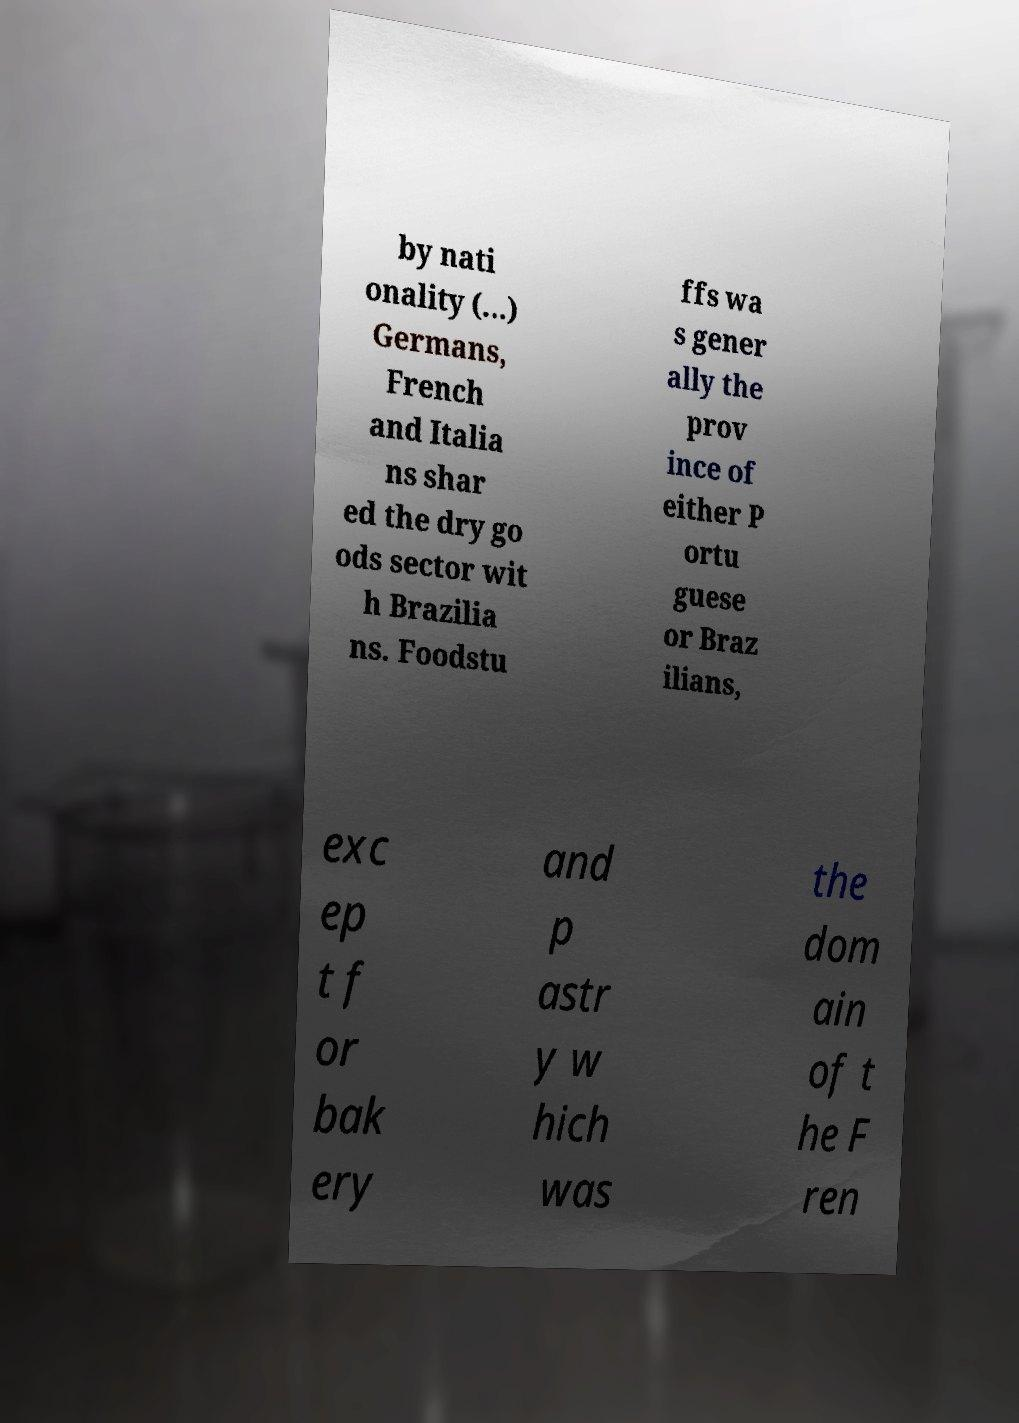What messages or text are displayed in this image? I need them in a readable, typed format. by nati onality (...) Germans, French and Italia ns shar ed the dry go ods sector wit h Brazilia ns. Foodstu ffs wa s gener ally the prov ince of either P ortu guese or Braz ilians, exc ep t f or bak ery and p astr y w hich was the dom ain of t he F ren 